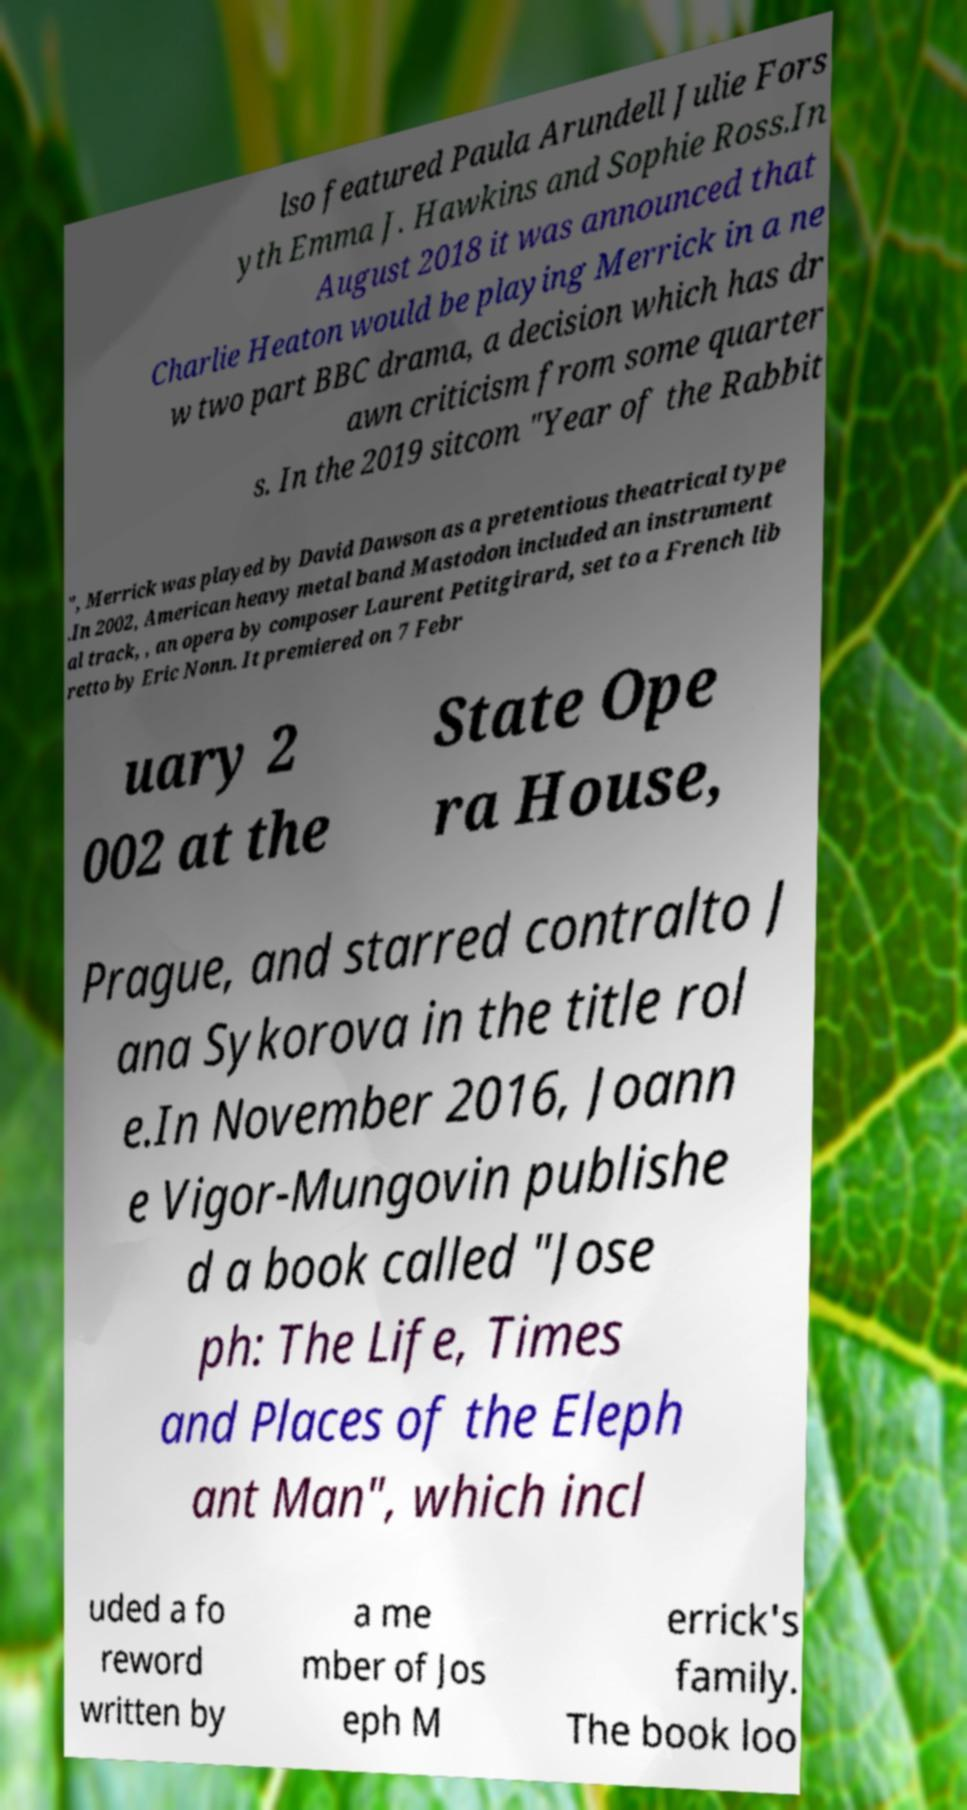There's text embedded in this image that I need extracted. Can you transcribe it verbatim? lso featured Paula Arundell Julie Fors yth Emma J. Hawkins and Sophie Ross.In August 2018 it was announced that Charlie Heaton would be playing Merrick in a ne w two part BBC drama, a decision which has dr awn criticism from some quarter s. In the 2019 sitcom "Year of the Rabbit ", Merrick was played by David Dawson as a pretentious theatrical type .In 2002, American heavy metal band Mastodon included an instrument al track, , an opera by composer Laurent Petitgirard, set to a French lib retto by Eric Nonn. It premiered on 7 Febr uary 2 002 at the State Ope ra House, Prague, and starred contralto J ana Sykorova in the title rol e.In November 2016, Joann e Vigor-Mungovin publishe d a book called "Jose ph: The Life, Times and Places of the Eleph ant Man", which incl uded a fo reword written by a me mber of Jos eph M errick's family. The book loo 